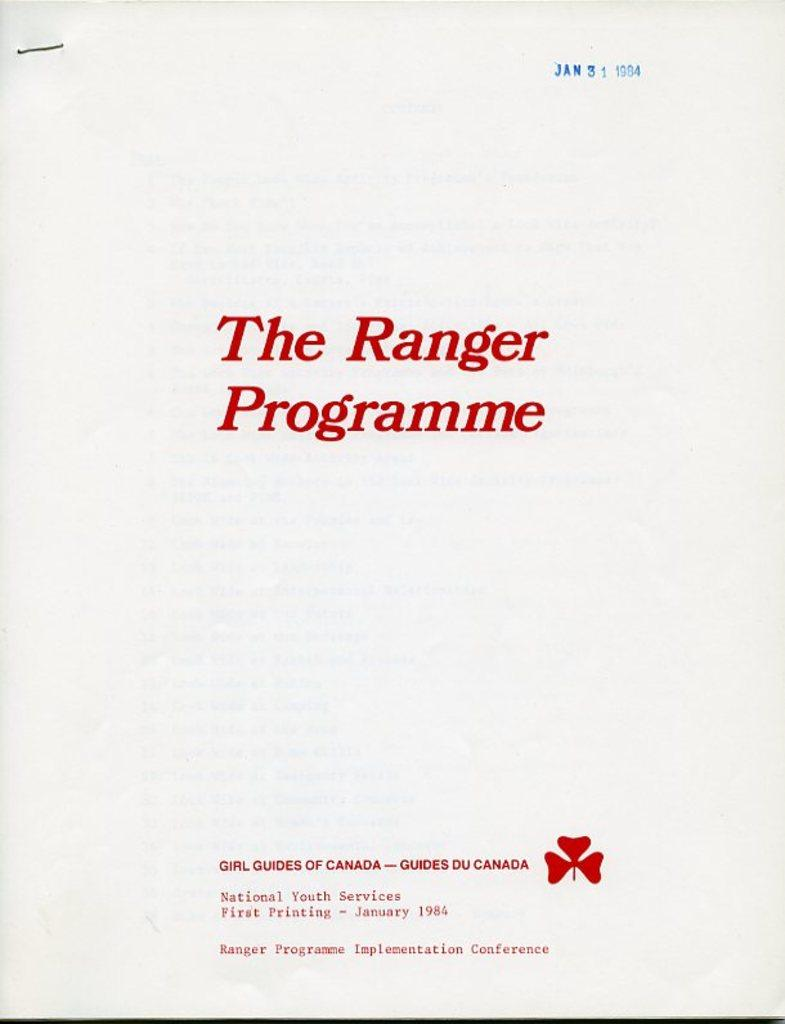<image>
Render a clear and concise summary of the photo. the front page of a paper that says The Ranger Programme 